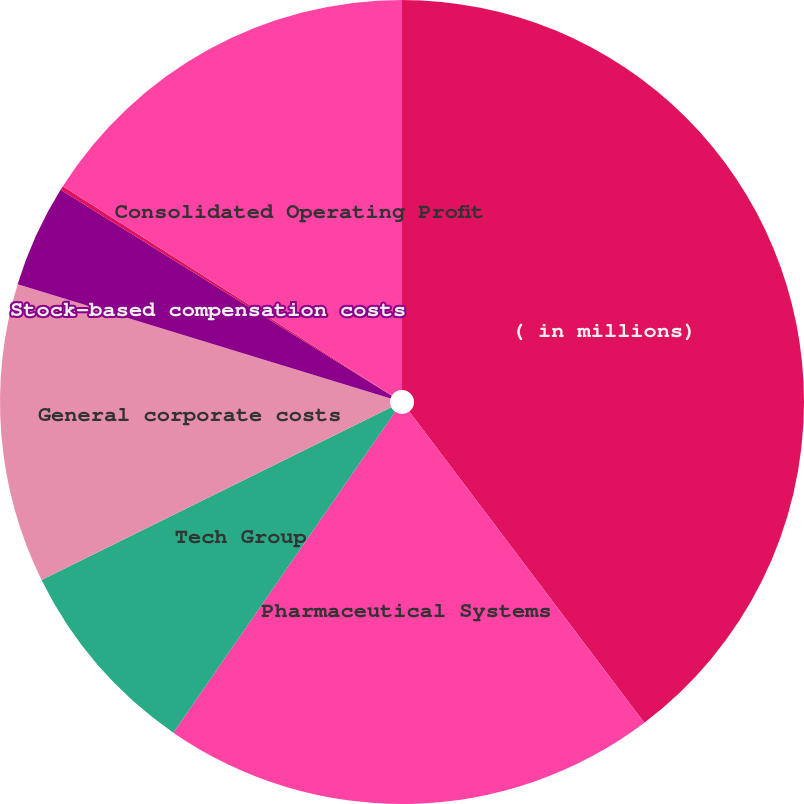Convert chart. <chart><loc_0><loc_0><loc_500><loc_500><pie_chart><fcel>( in millions)<fcel>Pharmaceutical Systems<fcel>Tech Group<fcel>General corporate costs<fcel>Stock-based compensation costs<fcel>US pension expenses<fcel>Consolidated Operating Profit<nl><fcel>39.7%<fcel>19.93%<fcel>8.07%<fcel>12.03%<fcel>4.12%<fcel>0.17%<fcel>15.98%<nl></chart> 